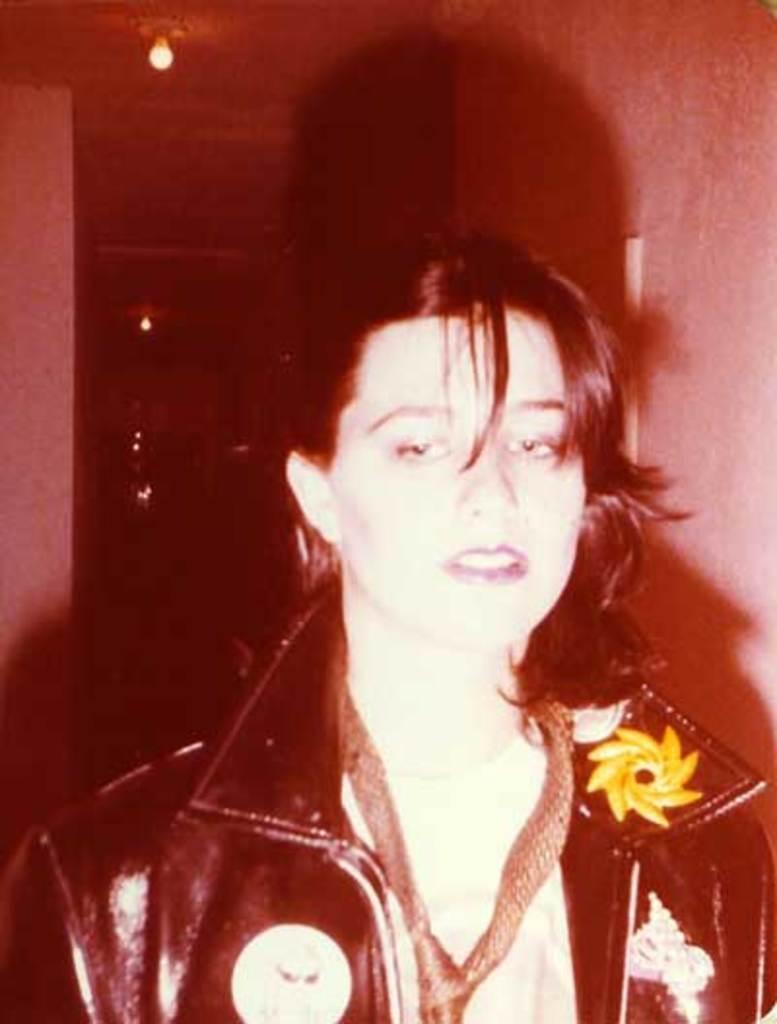Please provide a concise description of this image. In this picture there is a woman in the center wearing a black colour jacket. In the background there are lights on the top and there is a wall. 